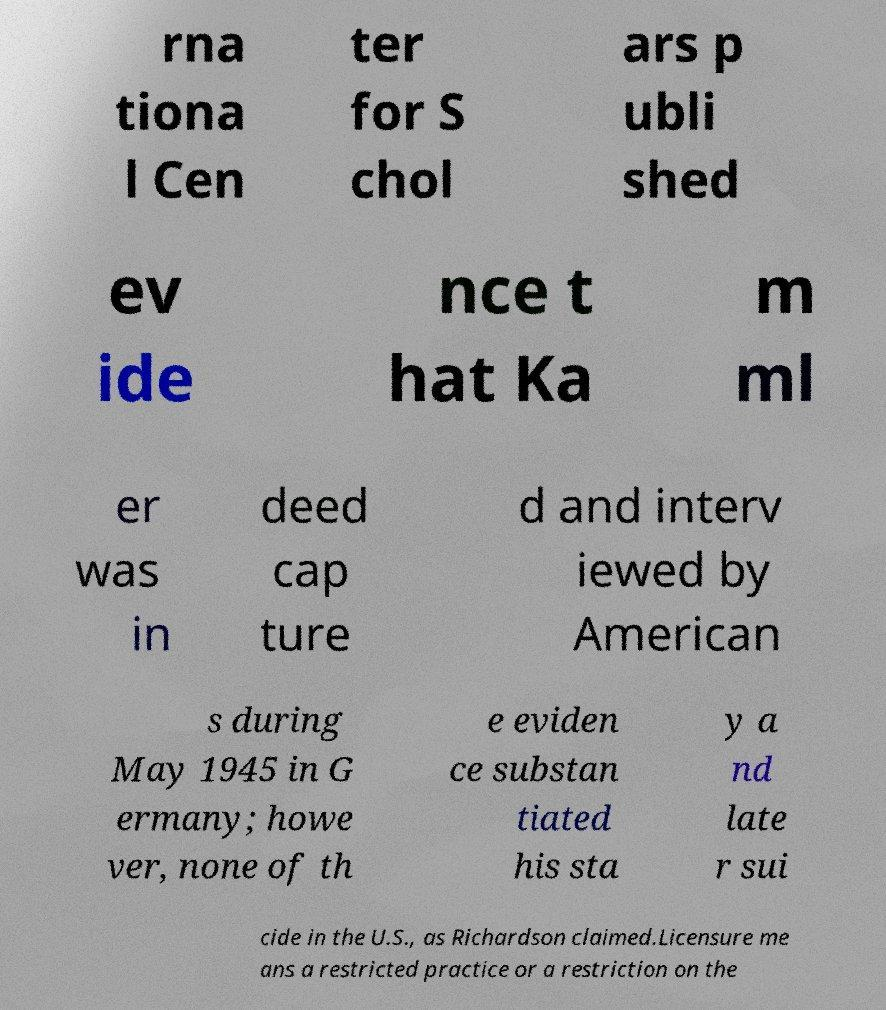Can you accurately transcribe the text from the provided image for me? rna tiona l Cen ter for S chol ars p ubli shed ev ide nce t hat Ka m ml er was in deed cap ture d and interv iewed by American s during May 1945 in G ermany; howe ver, none of th e eviden ce substan tiated his sta y a nd late r sui cide in the U.S., as Richardson claimed.Licensure me ans a restricted practice or a restriction on the 